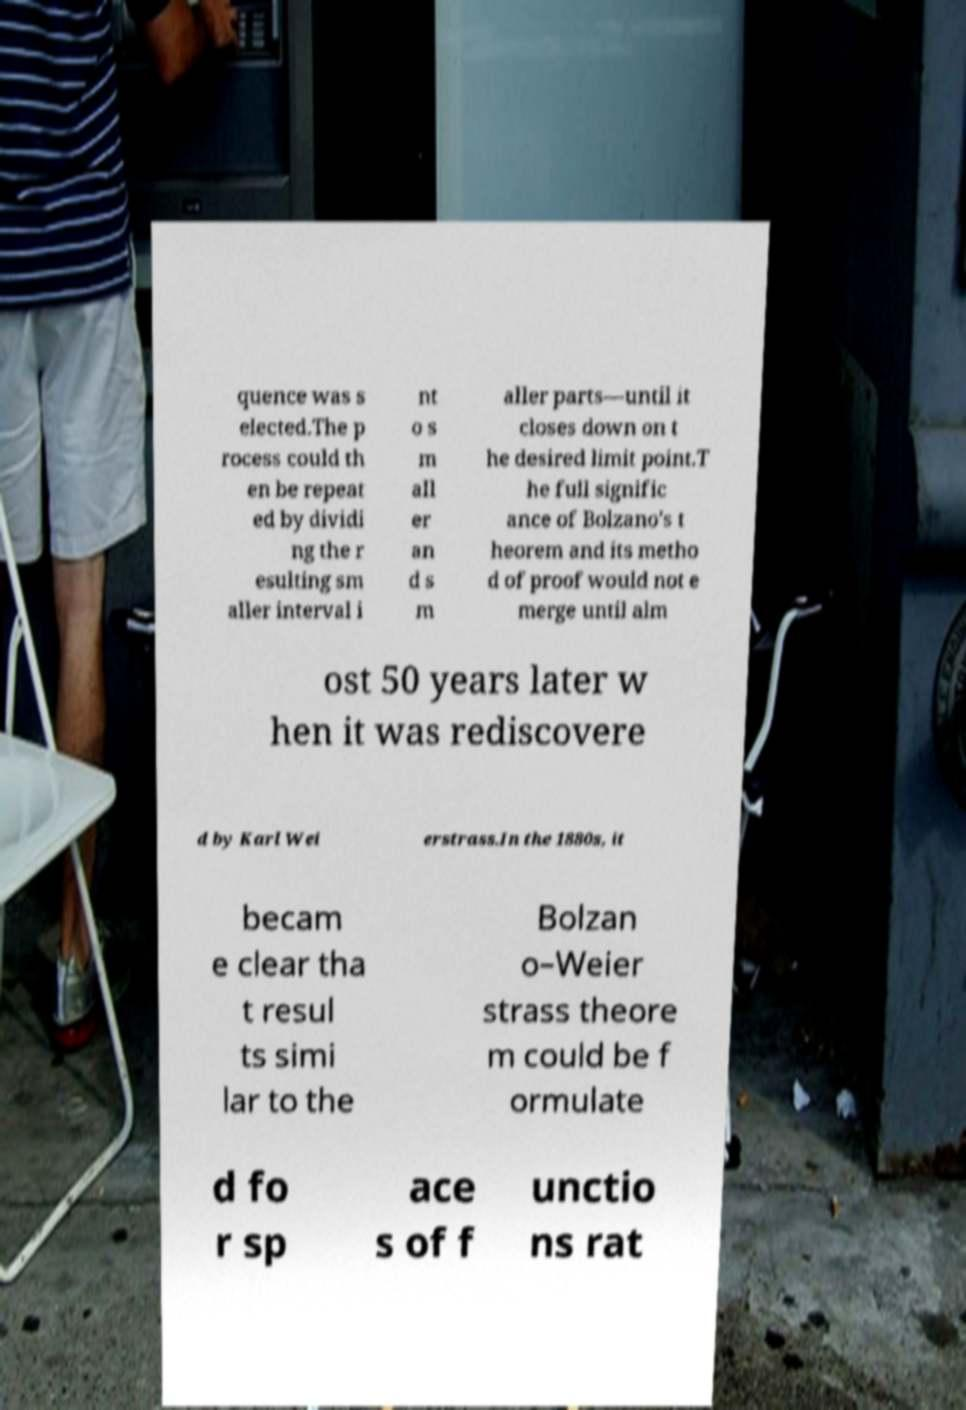There's text embedded in this image that I need extracted. Can you transcribe it verbatim? quence was s elected.The p rocess could th en be repeat ed by dividi ng the r esulting sm aller interval i nt o s m all er an d s m aller parts—until it closes down on t he desired limit point.T he full signific ance of Bolzano's t heorem and its metho d of proof would not e merge until alm ost 50 years later w hen it was rediscovere d by Karl Wei erstrass.In the 1880s, it becam e clear tha t resul ts simi lar to the Bolzan o–Weier strass theore m could be f ormulate d fo r sp ace s of f unctio ns rat 